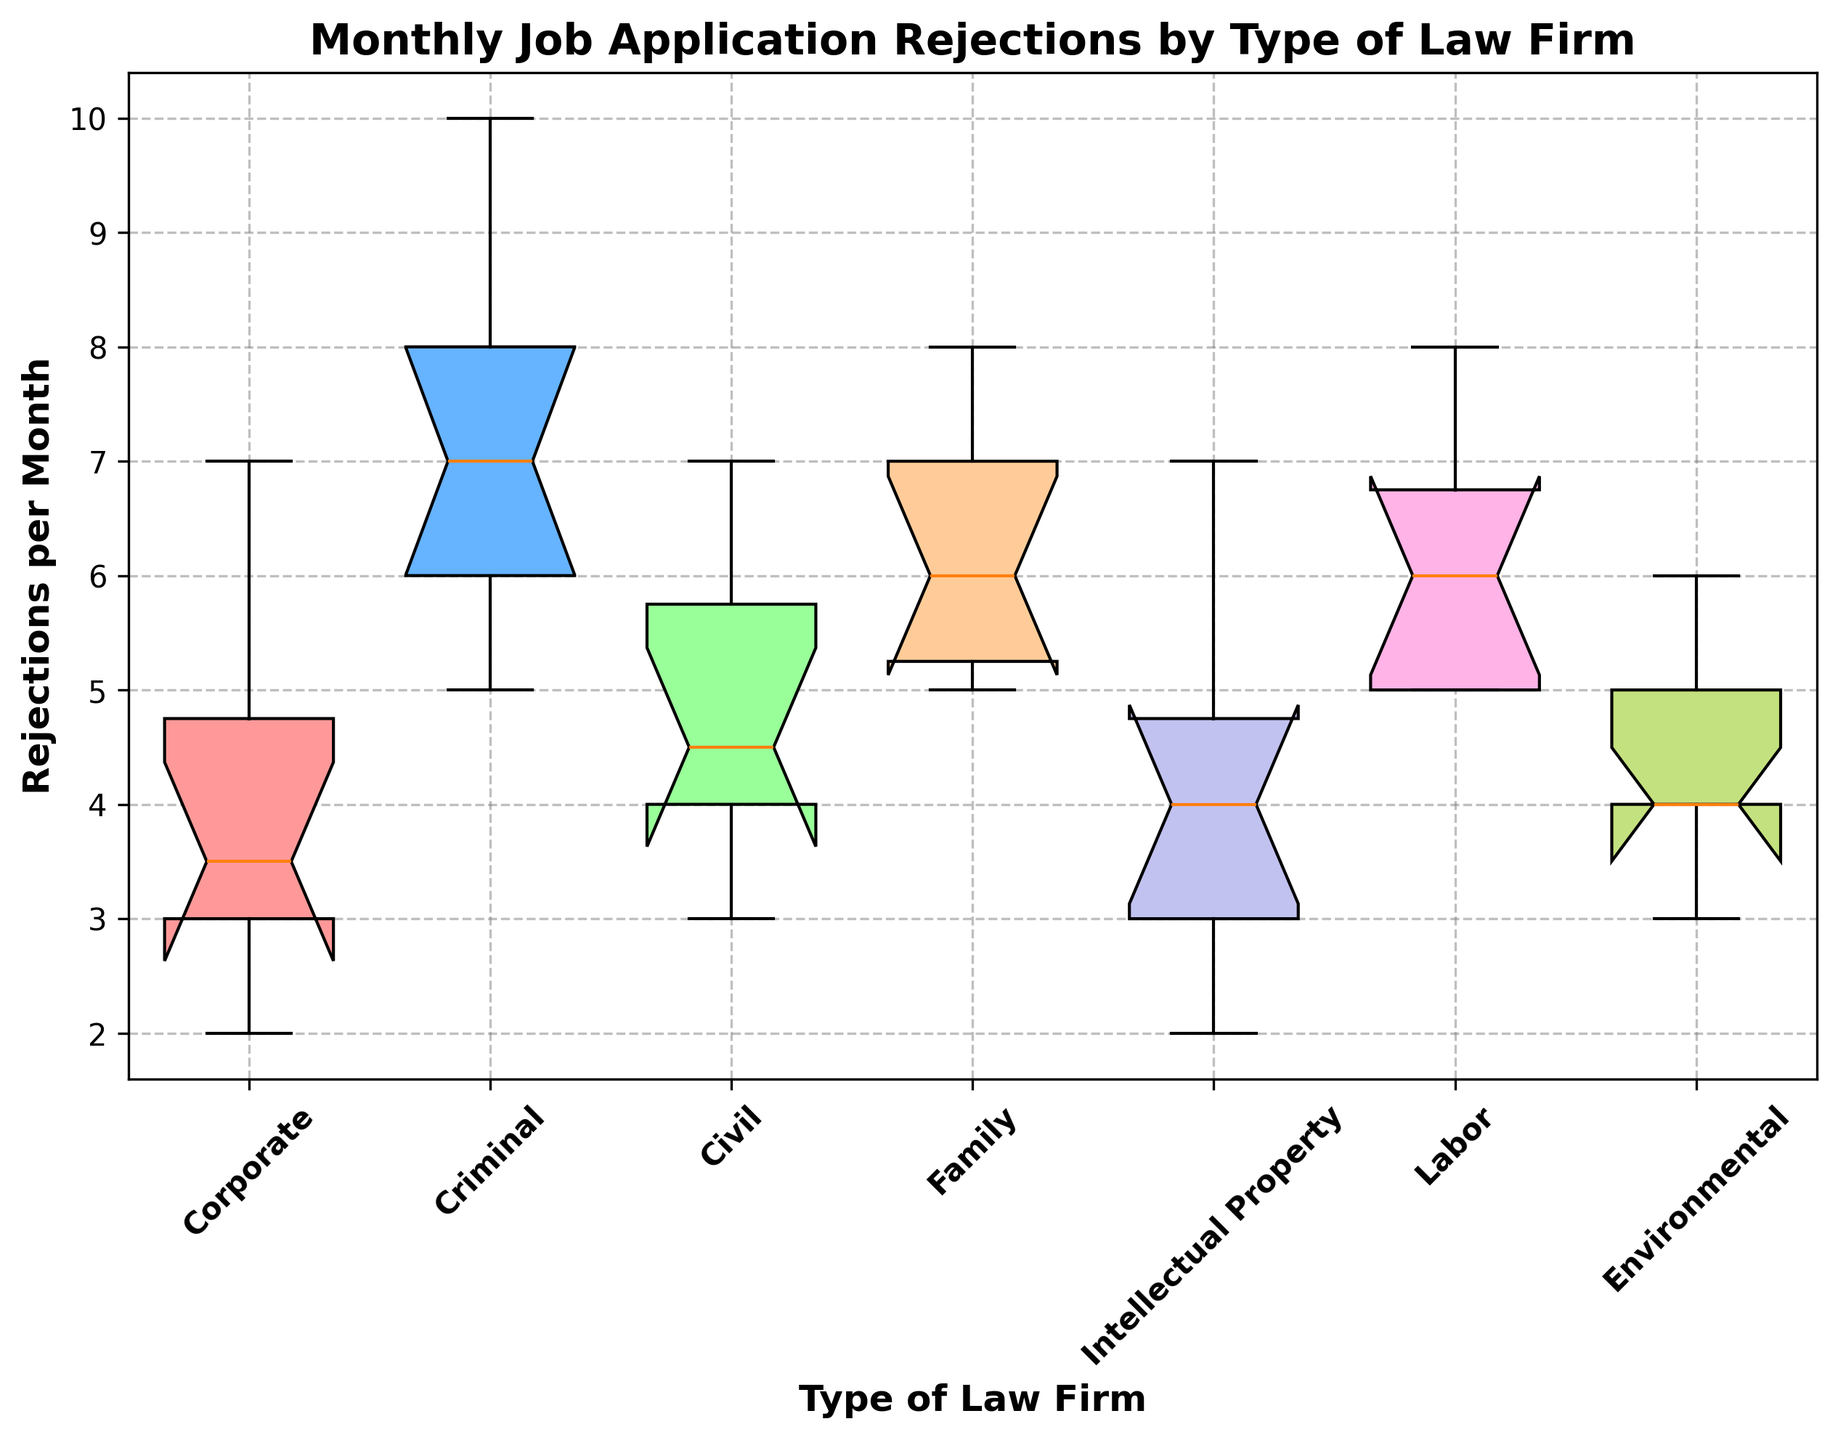What is the median number of monthly rejections for Corporate law firms? To find the median of Corporate law firm rejections, look at the box for Corporate on the box plot and find the line inside the box. This line represents the median value.
Answer: 3.5 Which type of law firm has the highest median number of monthly rejections? Compare the lines inside each of the boxes on the box plot. The highest line corresponds to the highest median value.
Answer: Criminal Are the monthly rejection counts more spread out for Criminal law firms or Corporate law firms? Check the length of the boxes (interquartile ranges) and the lengths of the whiskers for Criminal and Corporate law firms. The longer the boxes and whiskers, the more spread out the values are.
Answer: Criminal Which type of law firm has the widest interquartile range (IQR)? Look at the lengths of the boxes for each law firm type. The wider the box, the larger the IQR.
Answer: Criminal Are there any outliers in the data for Corporate law firms? Outliers are typically shown as individual points outside the whiskers of the box plot. Check for such individual points near the Corporate box.
Answer: No What is the range of the middle 50% of the data for Family law firms? The interquartile range (IQR) represents the range of the middle 50% of the data. Look at the length of the box for Family law firms.
Answer: 5 to 7 Which type of law firm has the smallest maximum value of monthly rejections? Check the top whisker ends of each box and identify the law firm type with the lowest top whisker.
Answer: Corporate How many rejections per month does the median of Environmental law firms fall between? Look at the line inside the box for Environmental law firms on the box plot. This line represents the median value, which falls between 4 and 5.
Answer: 4 to 5 Are the rejection rates for Civil law firms generally higher or lower than those for Labor law firms? Compare the positions of the boxes for Civil and Labor law firms. The higher position boxes indicate higher rejection rates.
Answer: Generally lower 